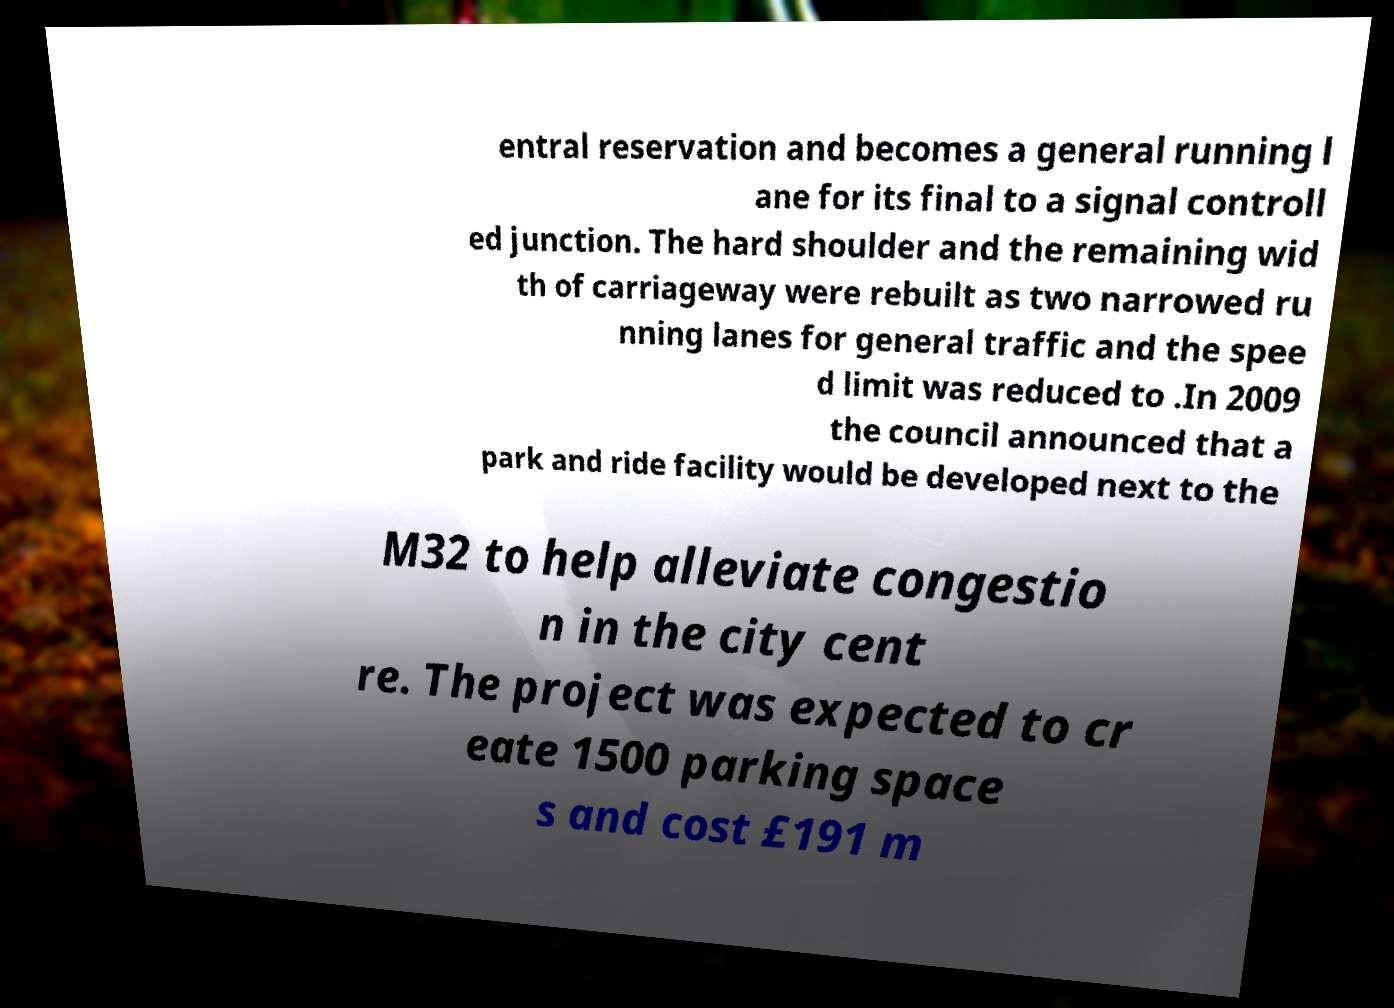Please read and relay the text visible in this image. What does it say? entral reservation and becomes a general running l ane for its final to a signal controll ed junction. The hard shoulder and the remaining wid th of carriageway were rebuilt as two narrowed ru nning lanes for general traffic and the spee d limit was reduced to .In 2009 the council announced that a park and ride facility would be developed next to the M32 to help alleviate congestio n in the city cent re. The project was expected to cr eate 1500 parking space s and cost £191 m 